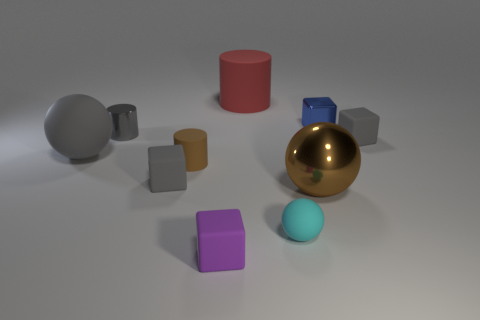How many big metal objects are there?
Provide a short and direct response. 1. What is the shape of the small gray thing that is made of the same material as the blue thing?
Make the answer very short. Cylinder. Is the color of the big sphere in front of the large gray matte ball the same as the cylinder in front of the small gray cylinder?
Provide a short and direct response. Yes. Are there the same number of large spheres that are on the right side of the small blue shiny cube and big purple balls?
Provide a short and direct response. Yes. What number of rubber cylinders are on the right side of the purple matte object?
Provide a short and direct response. 1. The brown metallic sphere has what size?
Your response must be concise. Large. There is another tiny sphere that is the same material as the gray sphere; what is its color?
Keep it short and to the point. Cyan. How many other green shiny balls are the same size as the metallic ball?
Your response must be concise. 0. Are the brown cylinder that is behind the big shiny thing and the small ball made of the same material?
Provide a succinct answer. Yes. Is the number of tiny cyan rubber things to the right of the gray sphere less than the number of blue objects?
Ensure brevity in your answer.  No. 